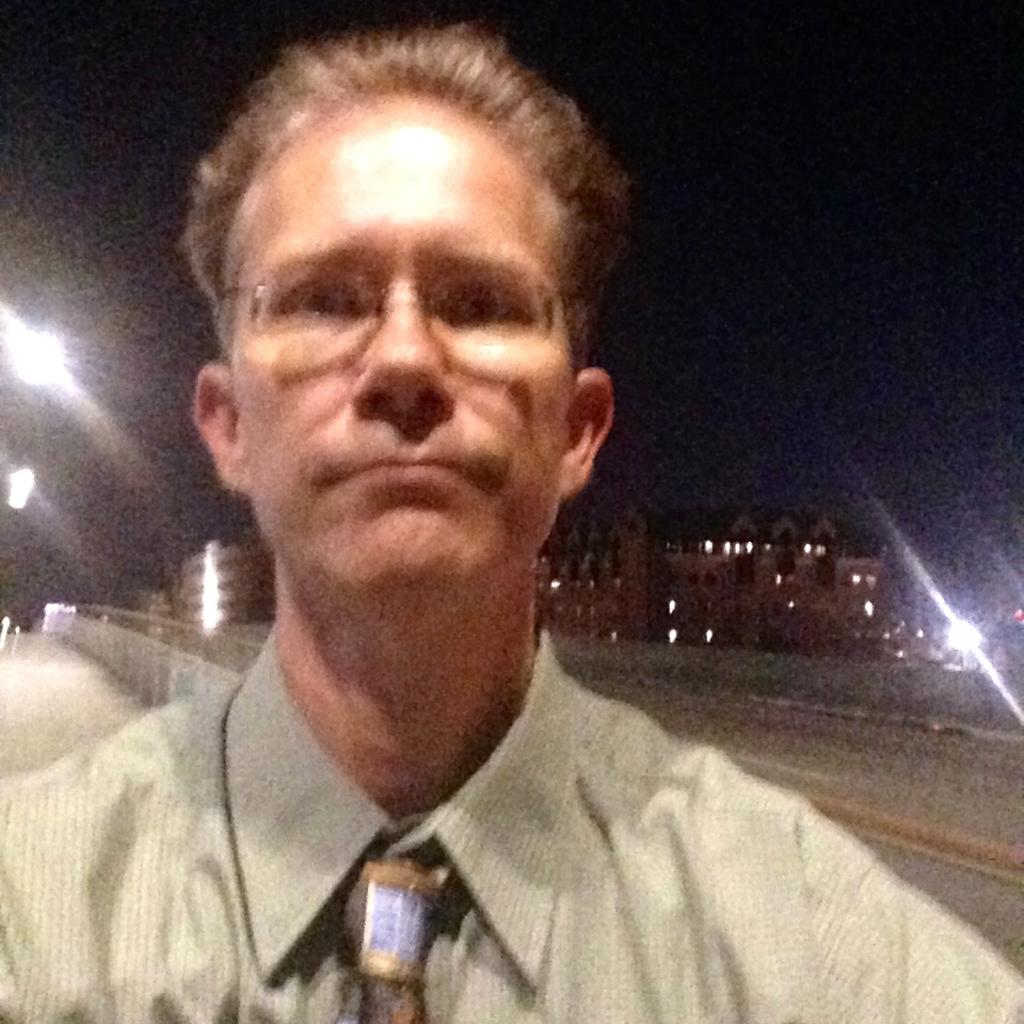Who is present in the image? There is a man in the image. What can be seen in the background of the image? There is a pathway, buildings, a fence, lights, and the sky visible in the background of the image. What grade of popcorn is being served at the concert in the image? There is no concert or popcorn present in the image. What type of music is being played in the background of the image? There is no music or indication of a musical event in the image. 